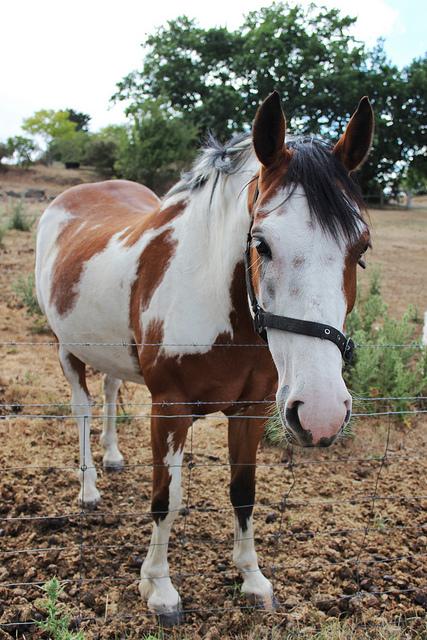Is this a pony?
Quick response, please. Yes. What color is the horse?
Short answer required. Brown and white. What is keeping the horse from moving forward?
Be succinct. Fence. 